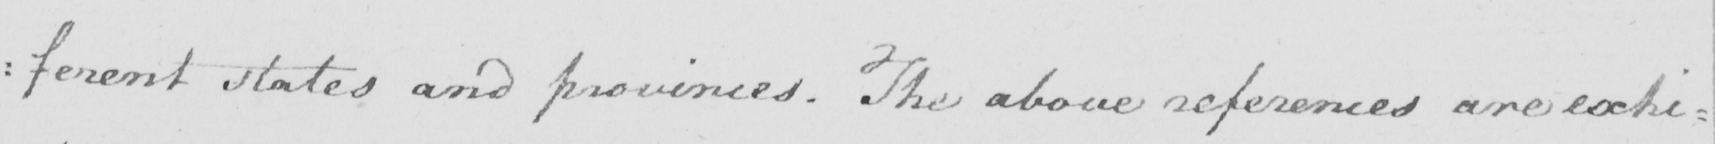Can you tell me what this handwritten text says? : ferent states and provinces . The above references are exhi : 